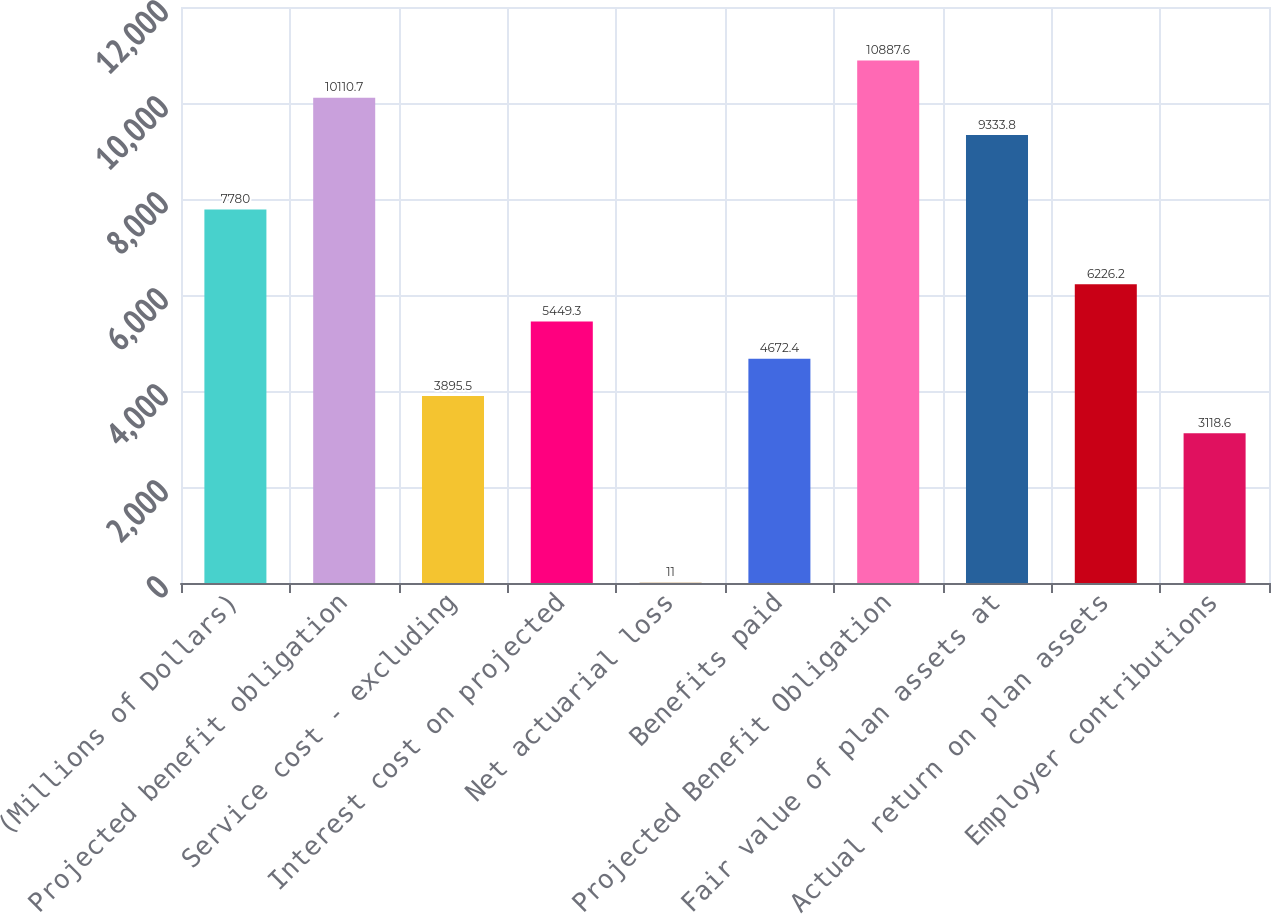<chart> <loc_0><loc_0><loc_500><loc_500><bar_chart><fcel>(Millions of Dollars)<fcel>Projected benefit obligation<fcel>Service cost - excluding<fcel>Interest cost on projected<fcel>Net actuarial loss<fcel>Benefits paid<fcel>Projected Benefit Obligation<fcel>Fair value of plan assets at<fcel>Actual return on plan assets<fcel>Employer contributions<nl><fcel>7780<fcel>10110.7<fcel>3895.5<fcel>5449.3<fcel>11<fcel>4672.4<fcel>10887.6<fcel>9333.8<fcel>6226.2<fcel>3118.6<nl></chart> 